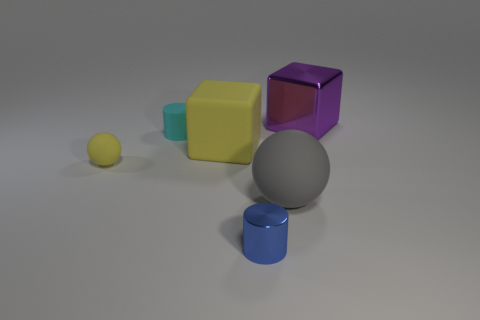Add 4 gray objects. How many objects exist? 10 Subtract all cylinders. How many objects are left? 4 Subtract 0 green balls. How many objects are left? 6 Subtract all balls. Subtract all gray matte balls. How many objects are left? 3 Add 5 spheres. How many spheres are left? 7 Add 6 large cubes. How many large cubes exist? 8 